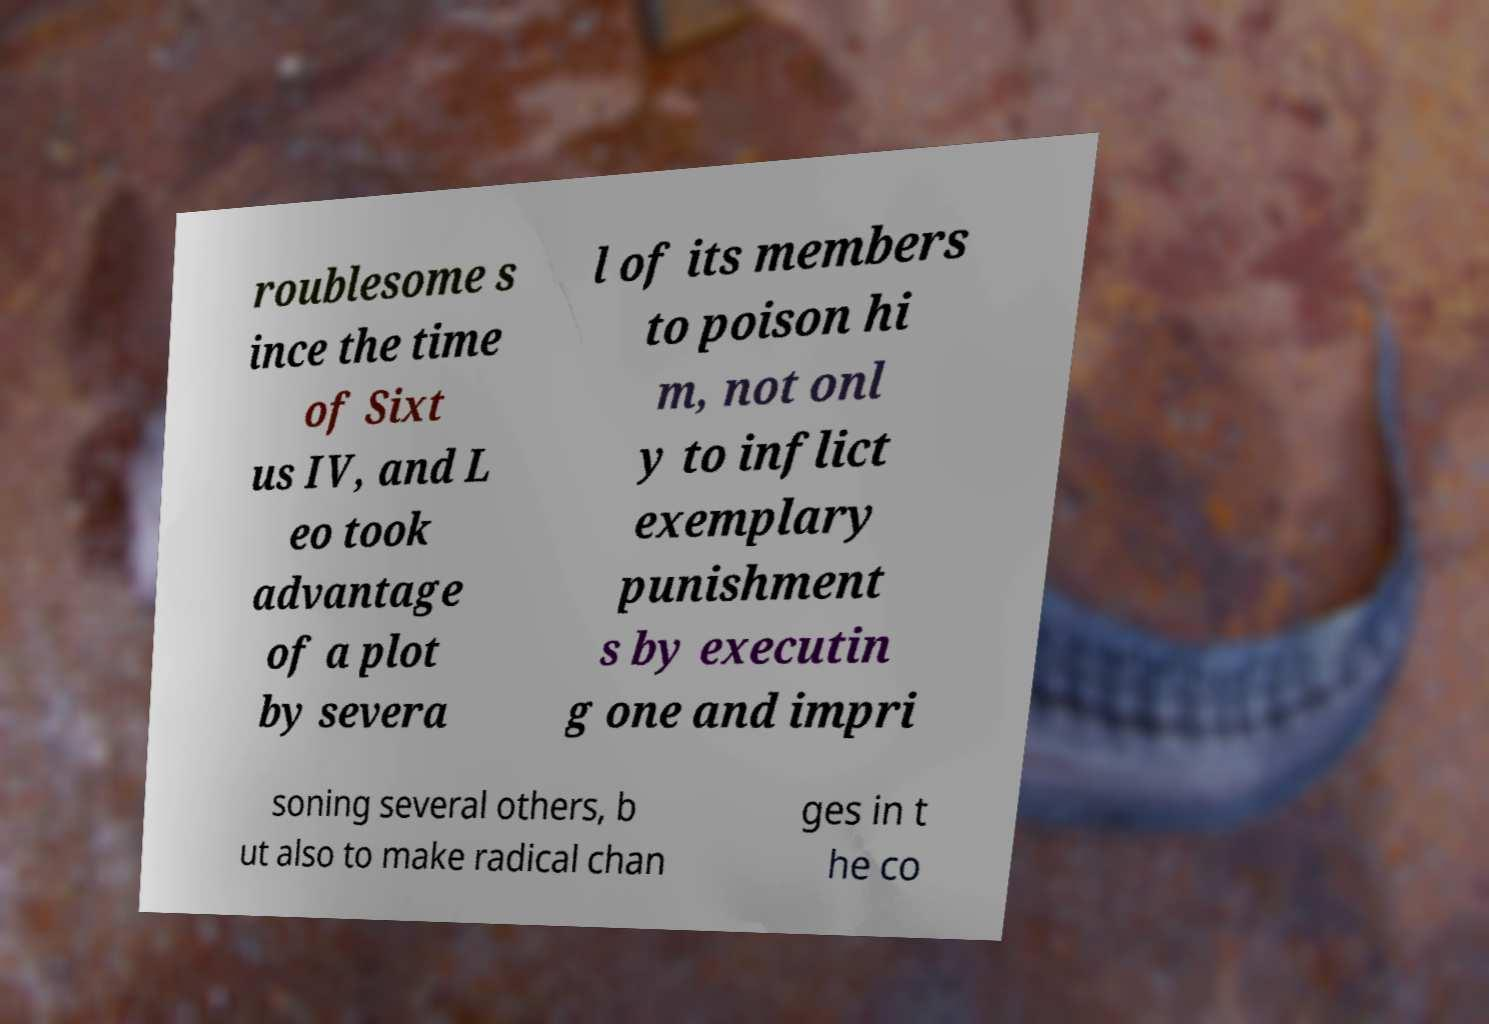For documentation purposes, I need the text within this image transcribed. Could you provide that? roublesome s ince the time of Sixt us IV, and L eo took advantage of a plot by severa l of its members to poison hi m, not onl y to inflict exemplary punishment s by executin g one and impri soning several others, b ut also to make radical chan ges in t he co 